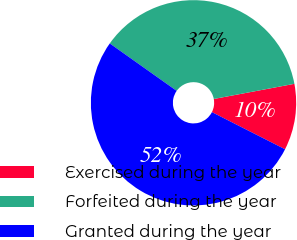<chart> <loc_0><loc_0><loc_500><loc_500><pie_chart><fcel>Exercised during the year<fcel>Forfeited during the year<fcel>Granted during the year<nl><fcel>10.44%<fcel>37.23%<fcel>52.34%<nl></chart> 